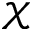<formula> <loc_0><loc_0><loc_500><loc_500>\mathcal { X }</formula> 